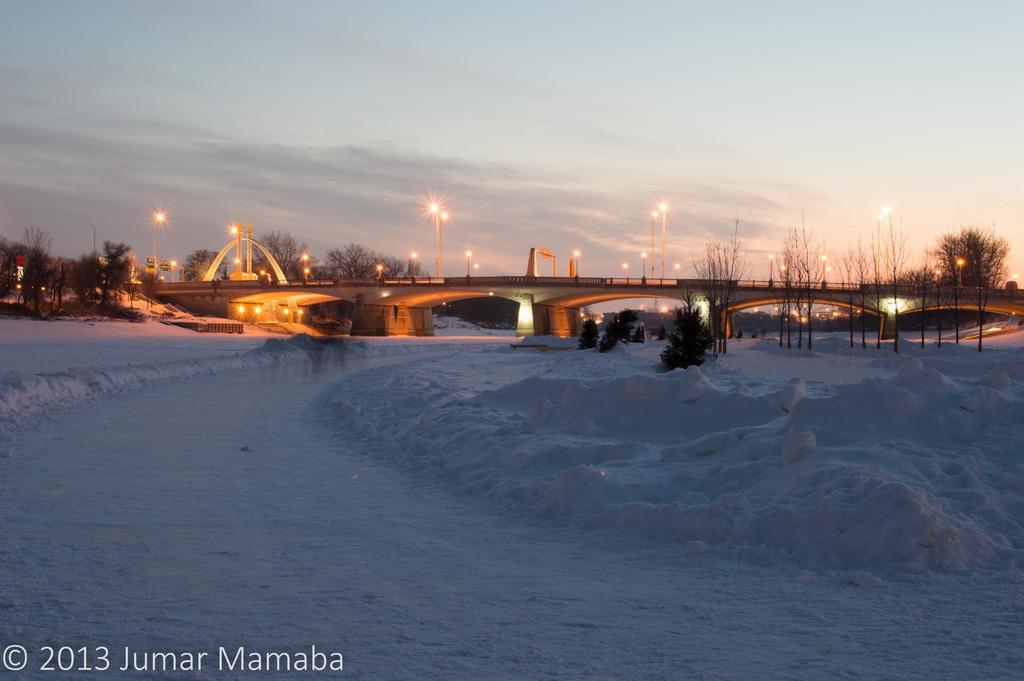What structure is the main subject of the image? There is a bridge in the image. What feature can be seen on the bridge? The bridge has street lights on it. What is the condition of the land below the bridge? Snow is present on the land below the bridge. What type of vegetation is visible in the image? There are plants visible in the image. What is visible in the background of the image? The sky is visible in the image, and clouds are present in the sky. Can you tell me how many rabbits are hopping on the bridge in the image? There are no rabbits present on the bridge in the image. What type of grape is being used to decorate the street lights on the bridge? There are no grapes present on the bridge or used to decorate the street lights in the image. 